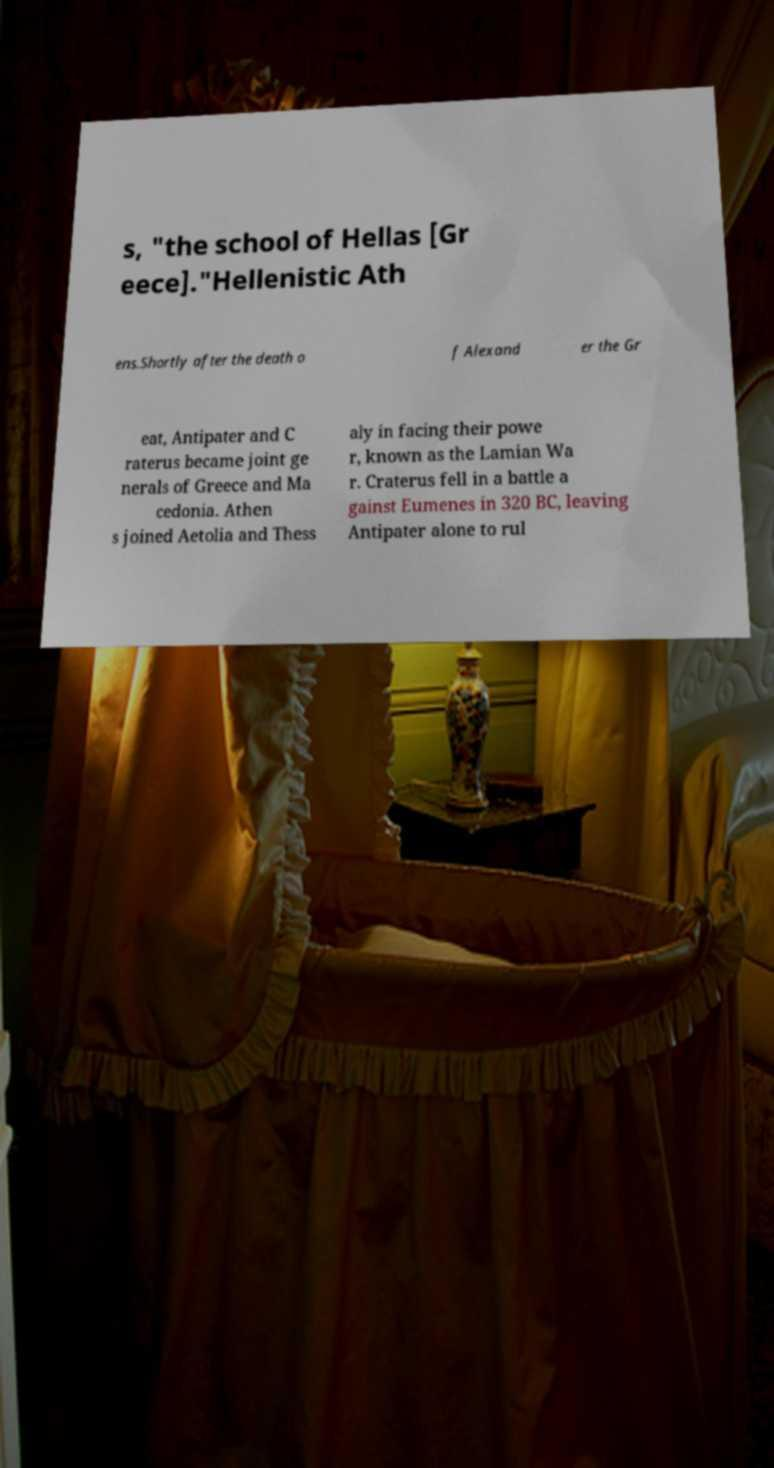For documentation purposes, I need the text within this image transcribed. Could you provide that? s, "the school of Hellas [Gr eece]."Hellenistic Ath ens.Shortly after the death o f Alexand er the Gr eat, Antipater and C raterus became joint ge nerals of Greece and Ma cedonia. Athen s joined Aetolia and Thess aly in facing their powe r, known as the Lamian Wa r. Craterus fell in a battle a gainst Eumenes in 320 BC, leaving Antipater alone to rul 